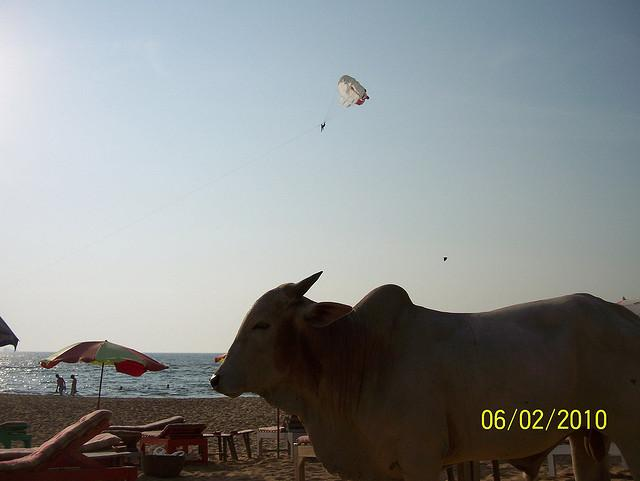What country is this beach located in? Please explain your reasoning. india. Cows are located in india. 